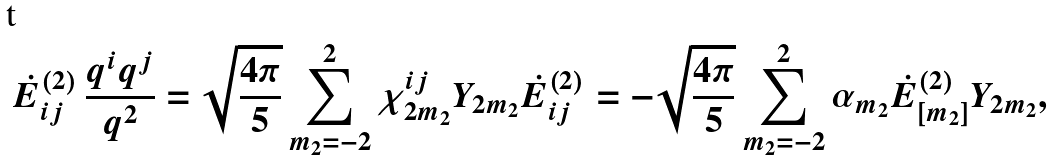Convert formula to latex. <formula><loc_0><loc_0><loc_500><loc_500>\dot { E } ^ { ( 2 ) } _ { i j } \, \frac { q ^ { i } q ^ { j } } { q ^ { 2 } } = \sqrt { \frac { 4 \pi } { 5 } } \sum _ { m _ { 2 } = - 2 } ^ { 2 } \chi _ { 2 m _ { 2 } } ^ { i j } Y _ { 2 m _ { 2 } } \dot { E } ^ { ( 2 ) } _ { i j } = - \sqrt { \frac { 4 \pi } { 5 } } \sum _ { m _ { 2 } = - 2 } ^ { 2 } \alpha _ { m _ { 2 } } \dot { E } ^ { ( 2 ) } _ { [ m _ { 2 } ] } Y _ { 2 m _ { 2 } } ,</formula> 